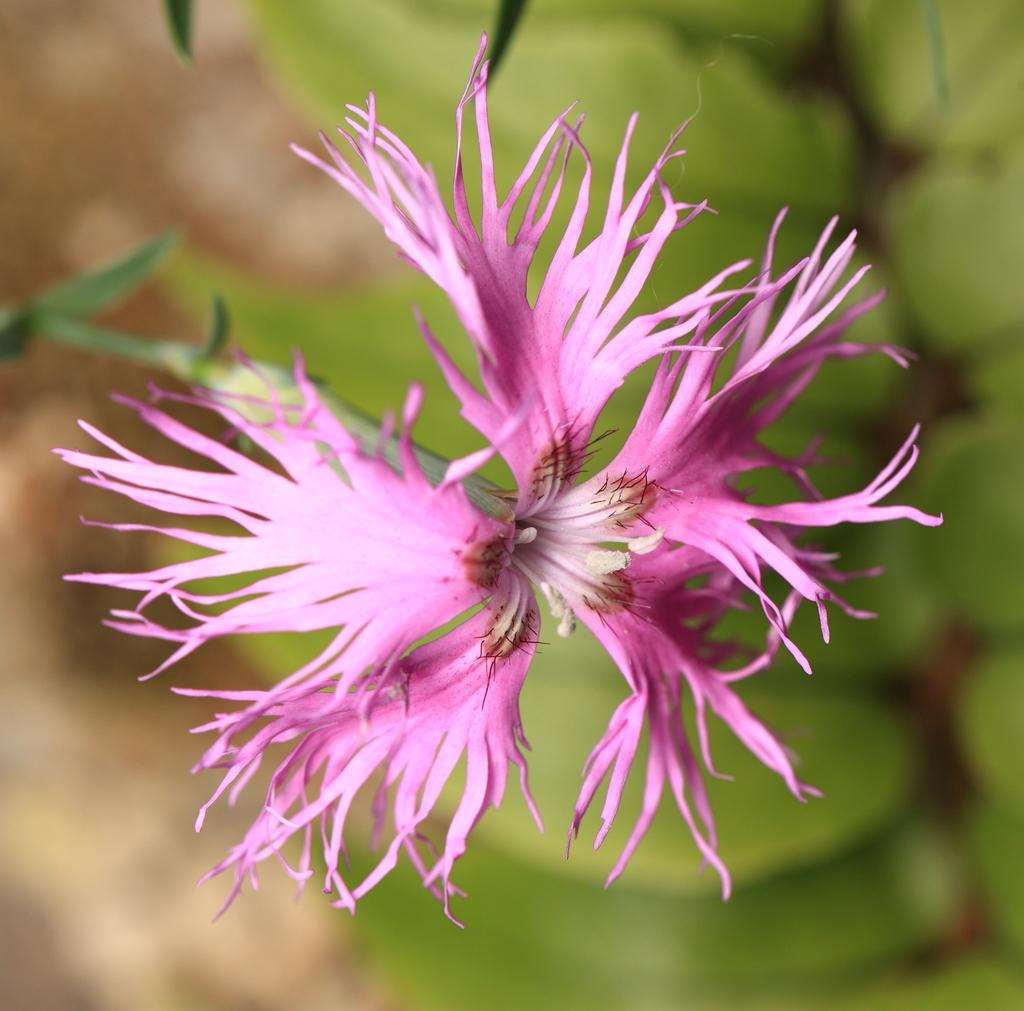What is the main subject of the image? There is a flower in the image. What color is the flower? The flower is pink in color. What color is the background of the image? The background is green in color. How is the background of the image depicted? The background is blurred. What type of square pattern can be seen on the shirt in the image? There is no shirt present in the image, and therefore no square pattern can be observed. 